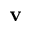Convert formula to latex. <formula><loc_0><loc_0><loc_500><loc_500>v</formula> 